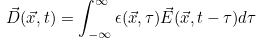<formula> <loc_0><loc_0><loc_500><loc_500>\vec { D } ( \vec { x } , t ) = \int _ { - \infty } ^ { \infty } \epsilon ( \vec { x } , \tau ) \vec { E } ( \vec { x } , t - \tau ) d \tau \\ \\</formula> 